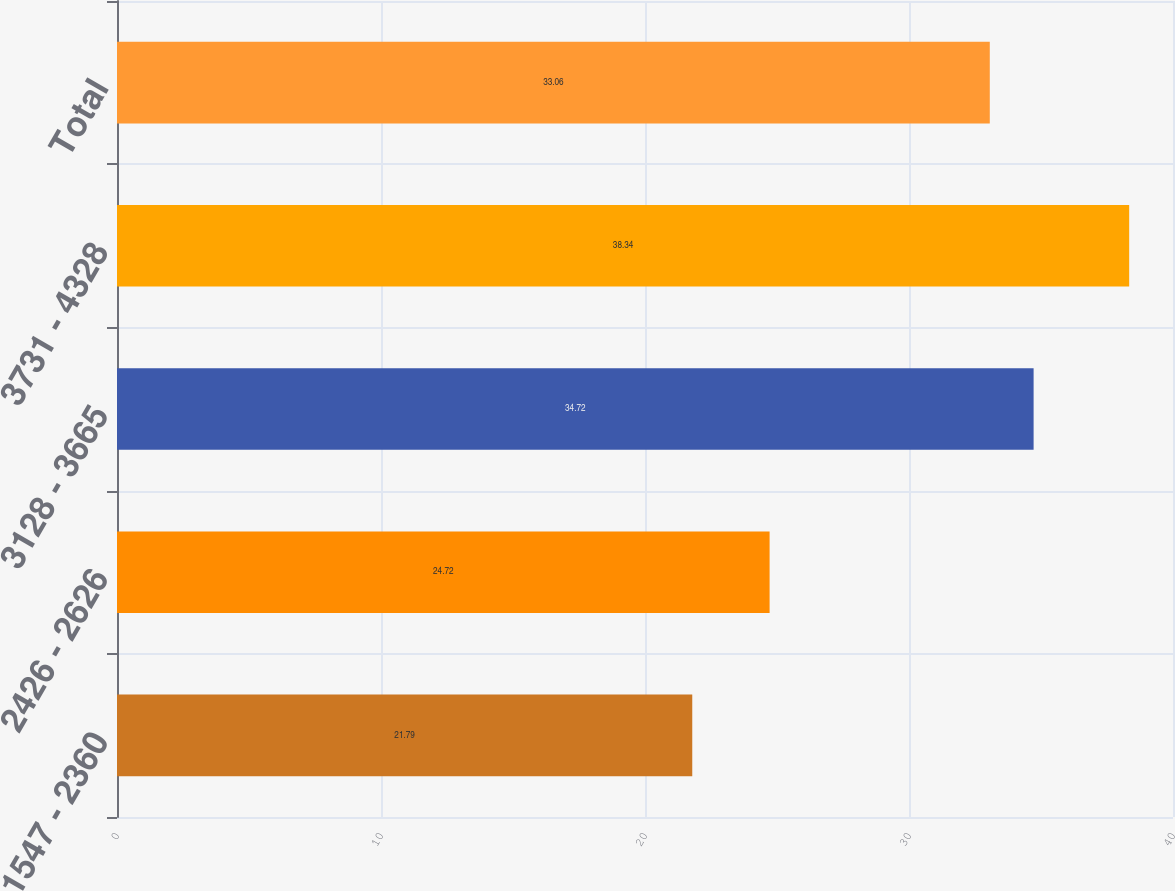Convert chart. <chart><loc_0><loc_0><loc_500><loc_500><bar_chart><fcel>1547 - 2360<fcel>2426 - 2626<fcel>3128 - 3665<fcel>3731 - 4328<fcel>Total<nl><fcel>21.79<fcel>24.72<fcel>34.72<fcel>38.34<fcel>33.06<nl></chart> 